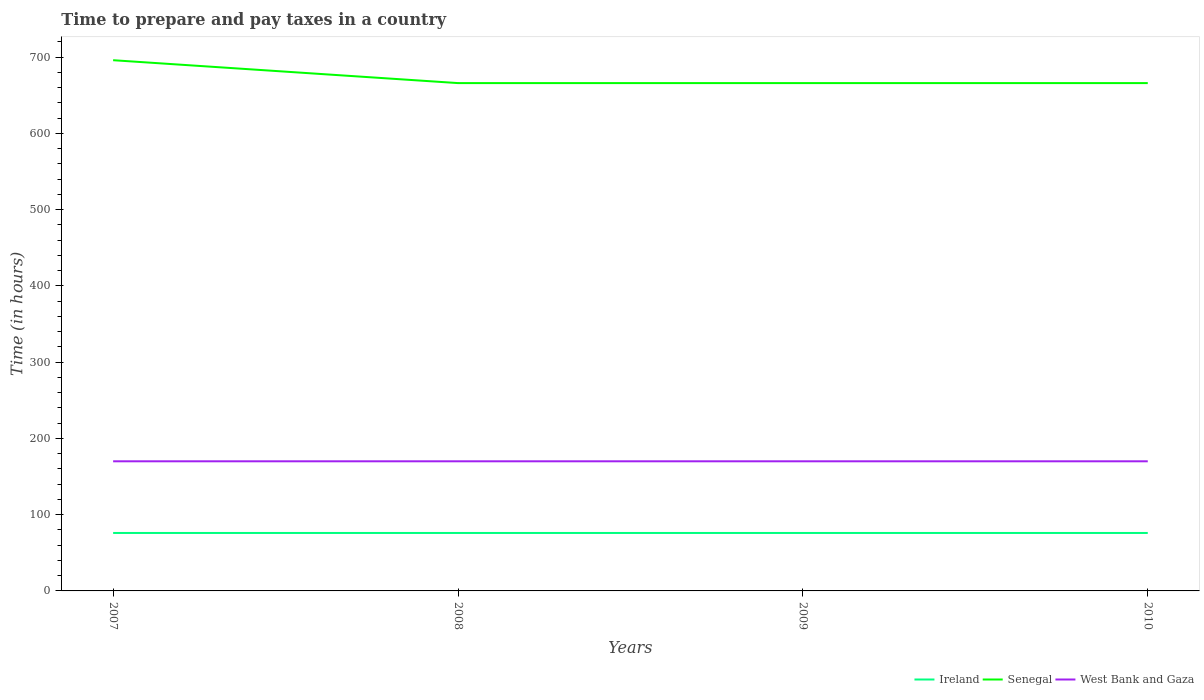Is the number of lines equal to the number of legend labels?
Offer a terse response. Yes. Across all years, what is the maximum number of hours required to prepare and pay taxes in West Bank and Gaza?
Your answer should be compact. 170. In which year was the number of hours required to prepare and pay taxes in West Bank and Gaza maximum?
Ensure brevity in your answer.  2007. What is the total number of hours required to prepare and pay taxes in Ireland in the graph?
Provide a short and direct response. 0. Is the number of hours required to prepare and pay taxes in Senegal strictly greater than the number of hours required to prepare and pay taxes in Ireland over the years?
Provide a succinct answer. No. How many years are there in the graph?
Make the answer very short. 4. Are the values on the major ticks of Y-axis written in scientific E-notation?
Offer a very short reply. No. Does the graph contain any zero values?
Make the answer very short. No. Does the graph contain grids?
Provide a short and direct response. No. How many legend labels are there?
Give a very brief answer. 3. How are the legend labels stacked?
Give a very brief answer. Horizontal. What is the title of the graph?
Provide a short and direct response. Time to prepare and pay taxes in a country. What is the label or title of the X-axis?
Your answer should be compact. Years. What is the label or title of the Y-axis?
Give a very brief answer. Time (in hours). What is the Time (in hours) of Ireland in 2007?
Your answer should be compact. 76. What is the Time (in hours) of Senegal in 2007?
Your answer should be compact. 696. What is the Time (in hours) in West Bank and Gaza in 2007?
Provide a short and direct response. 170. What is the Time (in hours) in Senegal in 2008?
Provide a succinct answer. 666. What is the Time (in hours) of West Bank and Gaza in 2008?
Make the answer very short. 170. What is the Time (in hours) of Senegal in 2009?
Make the answer very short. 666. What is the Time (in hours) of West Bank and Gaza in 2009?
Offer a very short reply. 170. What is the Time (in hours) of Ireland in 2010?
Keep it short and to the point. 76. What is the Time (in hours) of Senegal in 2010?
Provide a short and direct response. 666. What is the Time (in hours) of West Bank and Gaza in 2010?
Offer a terse response. 170. Across all years, what is the maximum Time (in hours) in Ireland?
Provide a succinct answer. 76. Across all years, what is the maximum Time (in hours) in Senegal?
Give a very brief answer. 696. Across all years, what is the maximum Time (in hours) in West Bank and Gaza?
Provide a succinct answer. 170. Across all years, what is the minimum Time (in hours) in Ireland?
Your answer should be very brief. 76. Across all years, what is the minimum Time (in hours) of Senegal?
Provide a short and direct response. 666. Across all years, what is the minimum Time (in hours) of West Bank and Gaza?
Your answer should be very brief. 170. What is the total Time (in hours) in Ireland in the graph?
Your answer should be very brief. 304. What is the total Time (in hours) of Senegal in the graph?
Keep it short and to the point. 2694. What is the total Time (in hours) in West Bank and Gaza in the graph?
Provide a succinct answer. 680. What is the difference between the Time (in hours) in Ireland in 2007 and that in 2008?
Your answer should be compact. 0. What is the difference between the Time (in hours) in Senegal in 2007 and that in 2008?
Provide a succinct answer. 30. What is the difference between the Time (in hours) of Ireland in 2007 and that in 2009?
Provide a short and direct response. 0. What is the difference between the Time (in hours) in Ireland in 2007 and that in 2010?
Offer a terse response. 0. What is the difference between the Time (in hours) in West Bank and Gaza in 2007 and that in 2010?
Make the answer very short. 0. What is the difference between the Time (in hours) of Ireland in 2008 and that in 2009?
Your response must be concise. 0. What is the difference between the Time (in hours) of West Bank and Gaza in 2008 and that in 2009?
Provide a short and direct response. 0. What is the difference between the Time (in hours) of Ireland in 2007 and the Time (in hours) of Senegal in 2008?
Provide a short and direct response. -590. What is the difference between the Time (in hours) of Ireland in 2007 and the Time (in hours) of West Bank and Gaza in 2008?
Your answer should be compact. -94. What is the difference between the Time (in hours) of Senegal in 2007 and the Time (in hours) of West Bank and Gaza in 2008?
Offer a very short reply. 526. What is the difference between the Time (in hours) of Ireland in 2007 and the Time (in hours) of Senegal in 2009?
Keep it short and to the point. -590. What is the difference between the Time (in hours) in Ireland in 2007 and the Time (in hours) in West Bank and Gaza in 2009?
Your answer should be very brief. -94. What is the difference between the Time (in hours) in Senegal in 2007 and the Time (in hours) in West Bank and Gaza in 2009?
Your answer should be compact. 526. What is the difference between the Time (in hours) of Ireland in 2007 and the Time (in hours) of Senegal in 2010?
Keep it short and to the point. -590. What is the difference between the Time (in hours) of Ireland in 2007 and the Time (in hours) of West Bank and Gaza in 2010?
Your answer should be very brief. -94. What is the difference between the Time (in hours) of Senegal in 2007 and the Time (in hours) of West Bank and Gaza in 2010?
Provide a succinct answer. 526. What is the difference between the Time (in hours) in Ireland in 2008 and the Time (in hours) in Senegal in 2009?
Keep it short and to the point. -590. What is the difference between the Time (in hours) in Ireland in 2008 and the Time (in hours) in West Bank and Gaza in 2009?
Your answer should be very brief. -94. What is the difference between the Time (in hours) in Senegal in 2008 and the Time (in hours) in West Bank and Gaza in 2009?
Your answer should be very brief. 496. What is the difference between the Time (in hours) of Ireland in 2008 and the Time (in hours) of Senegal in 2010?
Your answer should be very brief. -590. What is the difference between the Time (in hours) in Ireland in 2008 and the Time (in hours) in West Bank and Gaza in 2010?
Provide a short and direct response. -94. What is the difference between the Time (in hours) in Senegal in 2008 and the Time (in hours) in West Bank and Gaza in 2010?
Keep it short and to the point. 496. What is the difference between the Time (in hours) in Ireland in 2009 and the Time (in hours) in Senegal in 2010?
Ensure brevity in your answer.  -590. What is the difference between the Time (in hours) in Ireland in 2009 and the Time (in hours) in West Bank and Gaza in 2010?
Ensure brevity in your answer.  -94. What is the difference between the Time (in hours) in Senegal in 2009 and the Time (in hours) in West Bank and Gaza in 2010?
Keep it short and to the point. 496. What is the average Time (in hours) in Senegal per year?
Make the answer very short. 673.5. What is the average Time (in hours) in West Bank and Gaza per year?
Your answer should be very brief. 170. In the year 2007, what is the difference between the Time (in hours) in Ireland and Time (in hours) in Senegal?
Your answer should be very brief. -620. In the year 2007, what is the difference between the Time (in hours) in Ireland and Time (in hours) in West Bank and Gaza?
Offer a very short reply. -94. In the year 2007, what is the difference between the Time (in hours) in Senegal and Time (in hours) in West Bank and Gaza?
Your answer should be very brief. 526. In the year 2008, what is the difference between the Time (in hours) of Ireland and Time (in hours) of Senegal?
Ensure brevity in your answer.  -590. In the year 2008, what is the difference between the Time (in hours) of Ireland and Time (in hours) of West Bank and Gaza?
Offer a very short reply. -94. In the year 2008, what is the difference between the Time (in hours) of Senegal and Time (in hours) of West Bank and Gaza?
Give a very brief answer. 496. In the year 2009, what is the difference between the Time (in hours) in Ireland and Time (in hours) in Senegal?
Your answer should be compact. -590. In the year 2009, what is the difference between the Time (in hours) in Ireland and Time (in hours) in West Bank and Gaza?
Offer a terse response. -94. In the year 2009, what is the difference between the Time (in hours) of Senegal and Time (in hours) of West Bank and Gaza?
Ensure brevity in your answer.  496. In the year 2010, what is the difference between the Time (in hours) of Ireland and Time (in hours) of Senegal?
Offer a terse response. -590. In the year 2010, what is the difference between the Time (in hours) of Ireland and Time (in hours) of West Bank and Gaza?
Your answer should be compact. -94. In the year 2010, what is the difference between the Time (in hours) of Senegal and Time (in hours) of West Bank and Gaza?
Offer a very short reply. 496. What is the ratio of the Time (in hours) of Senegal in 2007 to that in 2008?
Provide a short and direct response. 1.04. What is the ratio of the Time (in hours) of West Bank and Gaza in 2007 to that in 2008?
Your answer should be compact. 1. What is the ratio of the Time (in hours) in Senegal in 2007 to that in 2009?
Provide a short and direct response. 1.04. What is the ratio of the Time (in hours) in West Bank and Gaza in 2007 to that in 2009?
Provide a succinct answer. 1. What is the ratio of the Time (in hours) of Ireland in 2007 to that in 2010?
Give a very brief answer. 1. What is the ratio of the Time (in hours) in Senegal in 2007 to that in 2010?
Make the answer very short. 1.04. What is the ratio of the Time (in hours) in West Bank and Gaza in 2007 to that in 2010?
Your answer should be compact. 1. What is the ratio of the Time (in hours) in Ireland in 2008 to that in 2009?
Your response must be concise. 1. What is the ratio of the Time (in hours) in Senegal in 2008 to that in 2009?
Offer a terse response. 1. What is the ratio of the Time (in hours) of Senegal in 2008 to that in 2010?
Your answer should be compact. 1. What is the ratio of the Time (in hours) of Senegal in 2009 to that in 2010?
Keep it short and to the point. 1. What is the difference between the highest and the second highest Time (in hours) in Senegal?
Make the answer very short. 30. What is the difference between the highest and the second highest Time (in hours) in West Bank and Gaza?
Offer a terse response. 0. What is the difference between the highest and the lowest Time (in hours) in Senegal?
Your response must be concise. 30. What is the difference between the highest and the lowest Time (in hours) of West Bank and Gaza?
Give a very brief answer. 0. 